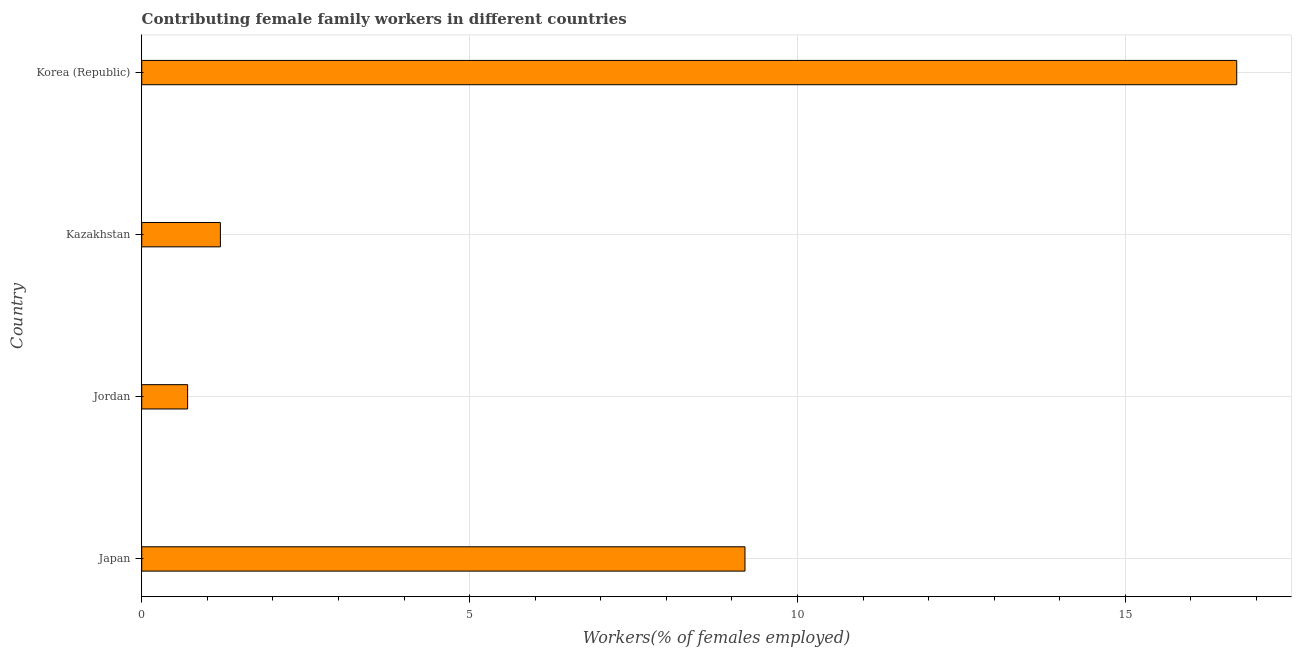Does the graph contain any zero values?
Your response must be concise. No. What is the title of the graph?
Give a very brief answer. Contributing female family workers in different countries. What is the label or title of the X-axis?
Your response must be concise. Workers(% of females employed). What is the label or title of the Y-axis?
Keep it short and to the point. Country. What is the contributing female family workers in Jordan?
Provide a succinct answer. 0.7. Across all countries, what is the maximum contributing female family workers?
Your answer should be compact. 16.7. Across all countries, what is the minimum contributing female family workers?
Keep it short and to the point. 0.7. In which country was the contributing female family workers minimum?
Your answer should be compact. Jordan. What is the sum of the contributing female family workers?
Offer a terse response. 27.8. What is the average contributing female family workers per country?
Your answer should be compact. 6.95. What is the median contributing female family workers?
Your response must be concise. 5.2. In how many countries, is the contributing female family workers greater than 13 %?
Your response must be concise. 1. What is the ratio of the contributing female family workers in Jordan to that in Kazakhstan?
Offer a very short reply. 0.58. Is the contributing female family workers in Japan less than that in Kazakhstan?
Your answer should be compact. No. Is the difference between the contributing female family workers in Kazakhstan and Korea (Republic) greater than the difference between any two countries?
Provide a short and direct response. No. Is the sum of the contributing female family workers in Japan and Jordan greater than the maximum contributing female family workers across all countries?
Your answer should be compact. No. What is the difference between the highest and the lowest contributing female family workers?
Your answer should be very brief. 16. In how many countries, is the contributing female family workers greater than the average contributing female family workers taken over all countries?
Offer a terse response. 2. Are all the bars in the graph horizontal?
Your answer should be compact. Yes. How many countries are there in the graph?
Give a very brief answer. 4. Are the values on the major ticks of X-axis written in scientific E-notation?
Give a very brief answer. No. What is the Workers(% of females employed) in Japan?
Provide a short and direct response. 9.2. What is the Workers(% of females employed) in Jordan?
Your answer should be very brief. 0.7. What is the Workers(% of females employed) of Kazakhstan?
Keep it short and to the point. 1.2. What is the Workers(% of females employed) of Korea (Republic)?
Your response must be concise. 16.7. What is the difference between the Workers(% of females employed) in Japan and Kazakhstan?
Give a very brief answer. 8. What is the difference between the Workers(% of females employed) in Japan and Korea (Republic)?
Provide a short and direct response. -7.5. What is the difference between the Workers(% of females employed) in Jordan and Korea (Republic)?
Provide a succinct answer. -16. What is the difference between the Workers(% of females employed) in Kazakhstan and Korea (Republic)?
Offer a terse response. -15.5. What is the ratio of the Workers(% of females employed) in Japan to that in Jordan?
Ensure brevity in your answer.  13.14. What is the ratio of the Workers(% of females employed) in Japan to that in Kazakhstan?
Make the answer very short. 7.67. What is the ratio of the Workers(% of females employed) in Japan to that in Korea (Republic)?
Give a very brief answer. 0.55. What is the ratio of the Workers(% of females employed) in Jordan to that in Kazakhstan?
Offer a terse response. 0.58. What is the ratio of the Workers(% of females employed) in Jordan to that in Korea (Republic)?
Give a very brief answer. 0.04. What is the ratio of the Workers(% of females employed) in Kazakhstan to that in Korea (Republic)?
Your answer should be compact. 0.07. 